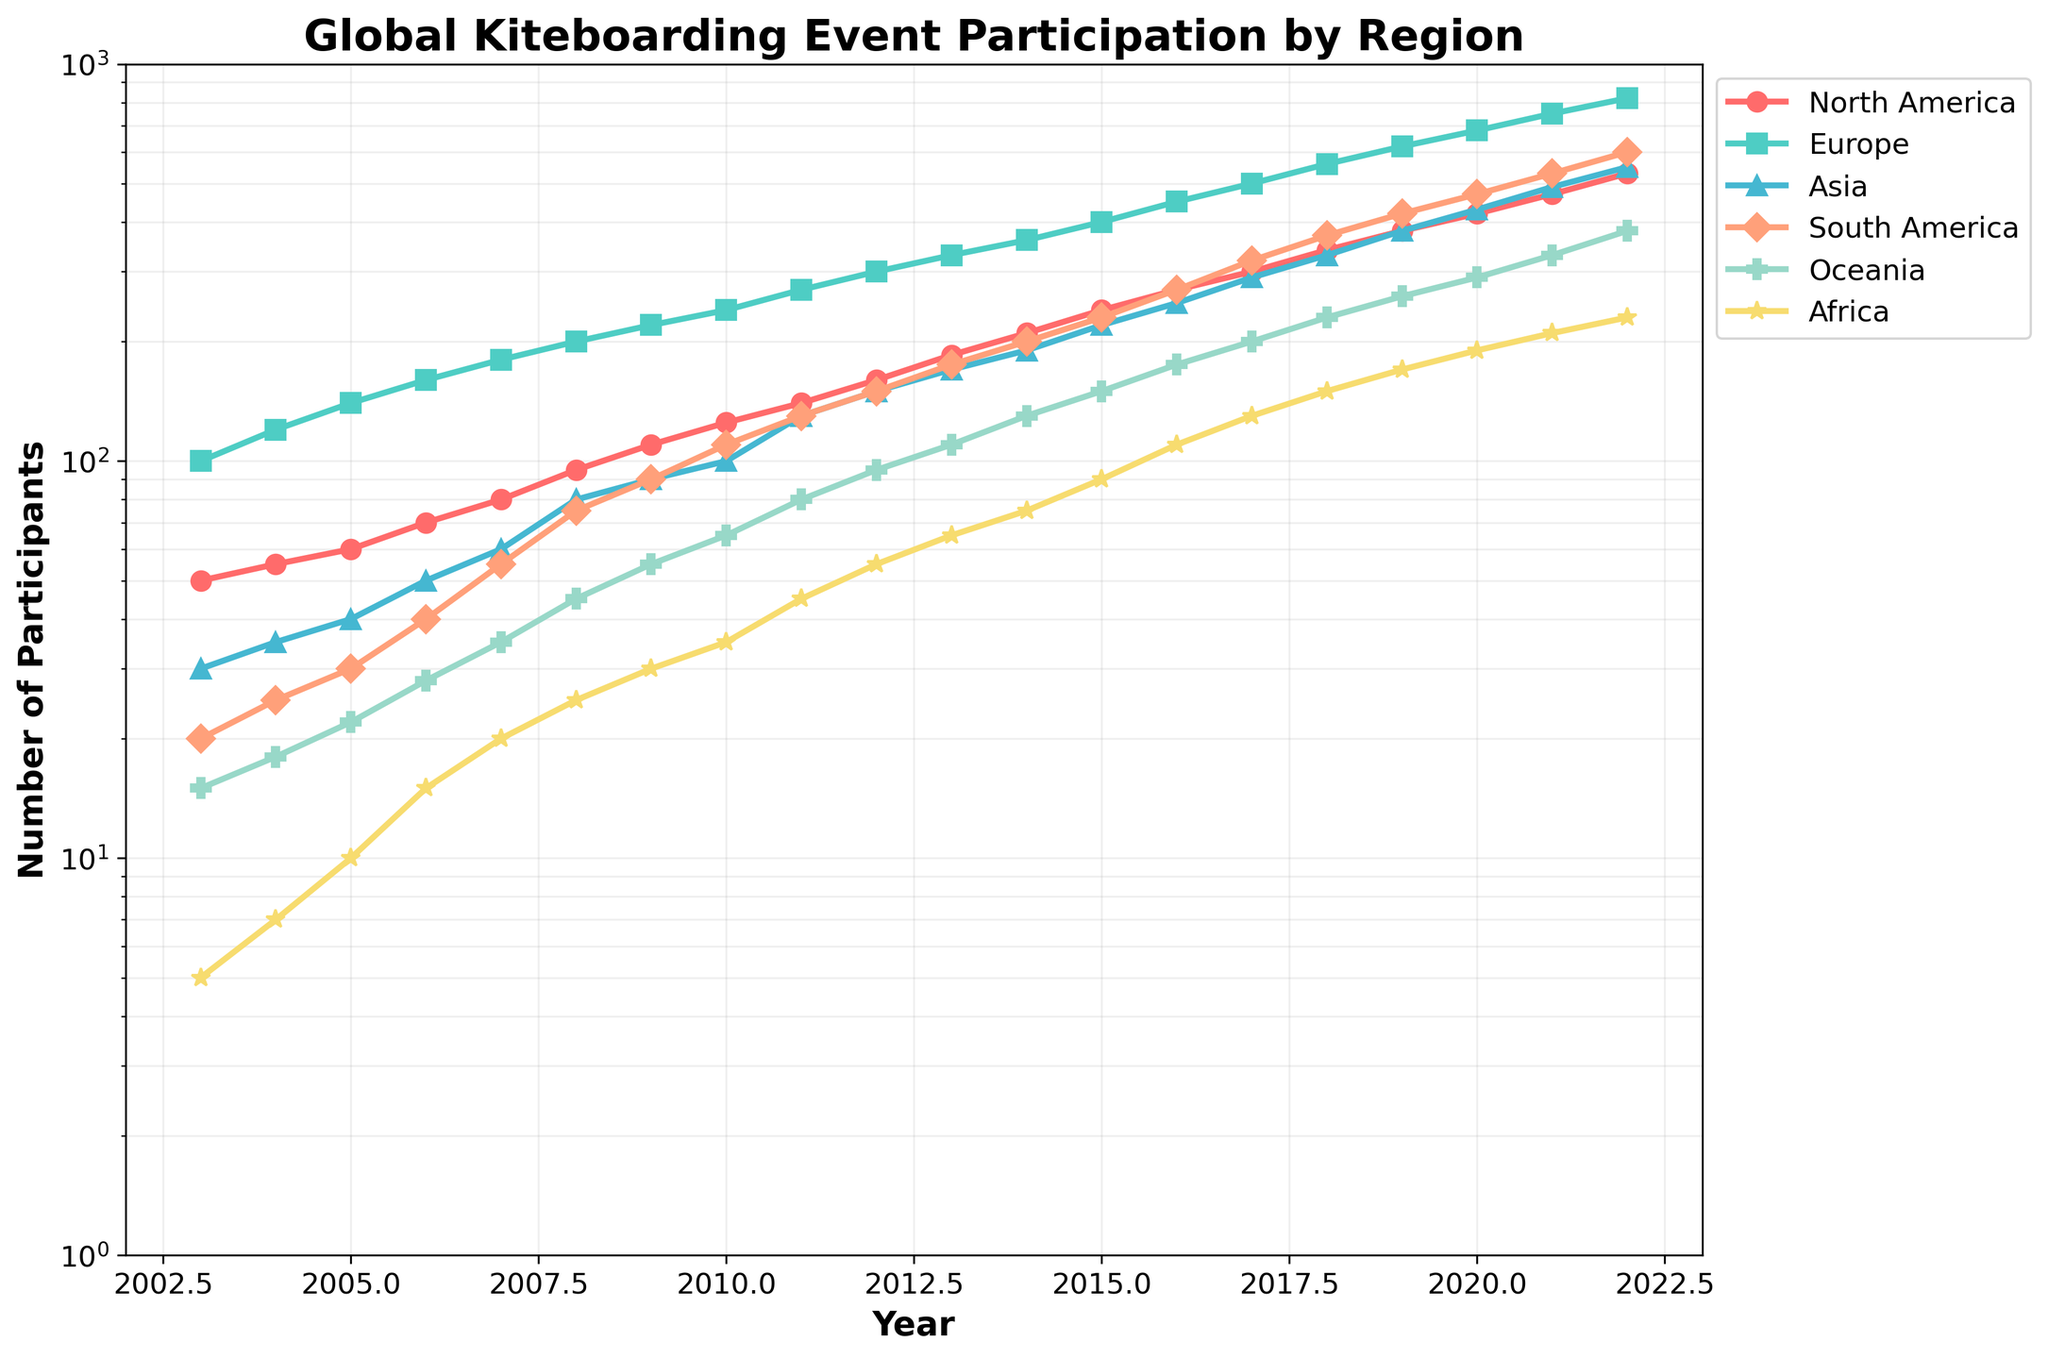What is the title of the plot? The title of the plot is usually located at the top center of the graph. It provides a summary of the content and purpose of the graph.
Answer: Global Kiteboarding Event Participation by Region Which region had the highest participation in 2022? By looking at the data points for 2022 on the log scale, the line and marker with the highest position on the y-axis represent the region.
Answer: Europe How many regions are represented in the plot? Each color and marker type represent a different region. Counting them will give the total number of regions.
Answer: 6 What was the approximate number of participants in Asia in 2015? Locate the year 2015 on the x-axis, then follow the line representing Asia to find the matching y-axis value.
Answer: 220 How did the number of participants in North America change from 2003 to 2007? Compare the data points for North America in 2003 and 2007 and calculate the difference.
Answer: Increased by 30 participants Which two regions had almost the same number of participants in 2012? Look for the data points in 2012 for all regions and identify which two are closest together.
Answer: South America and Oceania By approximately how many participants did Africa's numbers increase between 2010 and 2015? Find the data points for Africa in 2010 and 2015, then calculate the difference.
Answer: Increased by 55 participants Which region showed the most significant growth trend over the 20 years? Observe the steepness of the slope for each region. The steepest slope indicates the most significant growth trend.
Answer: Europe At what point did South America surpass 200 participants? Look at the trend line for South America and identify the year where it first goes above the 200 mark on the y-axis.
Answer: 2014 Comparing 2020 and 2021, which region had the smallest increase in participants? Compare the data points for all regions between 2020 and 2021 and find the smallest difference.
Answer: Africa 